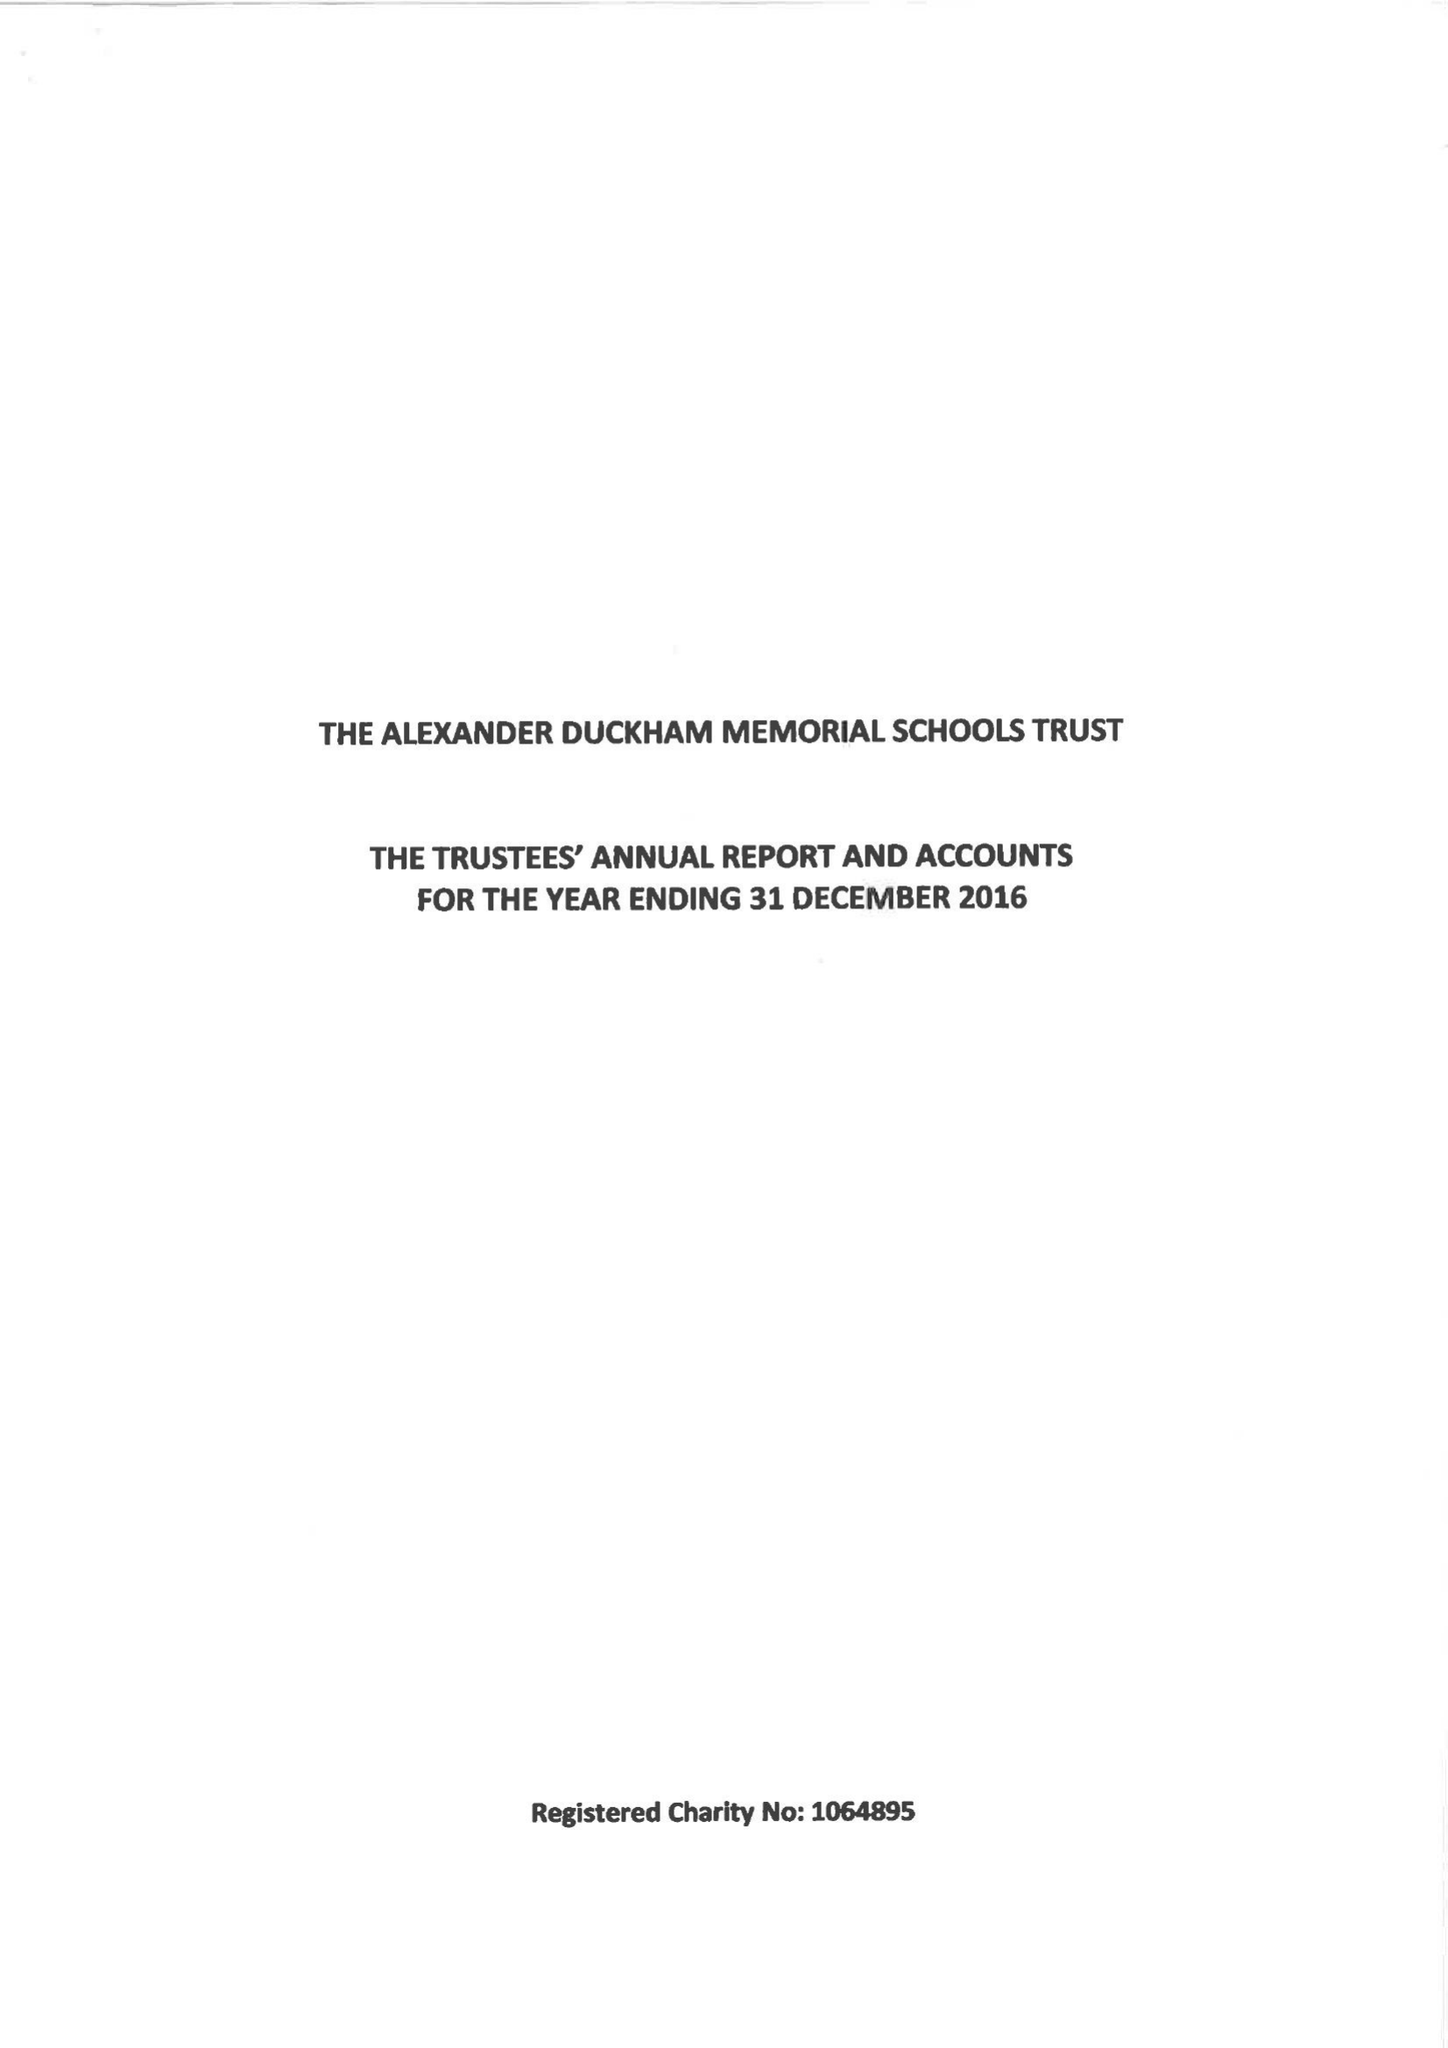What is the value for the address__post_town?
Answer the question using a single word or phrase. LONDON 